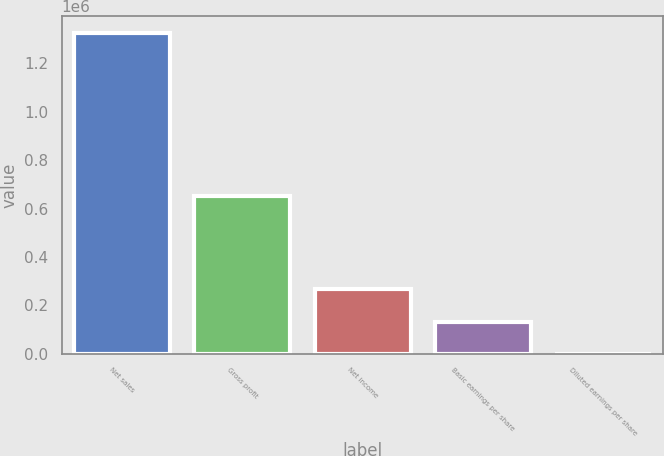Convert chart to OTSL. <chart><loc_0><loc_0><loc_500><loc_500><bar_chart><fcel>Net sales<fcel>Gross profit<fcel>Net income<fcel>Basic earnings per share<fcel>Diluted earnings per share<nl><fcel>1.32757e+06<fcel>650738<fcel>265515<fcel>132758<fcel>0.9<nl></chart> 